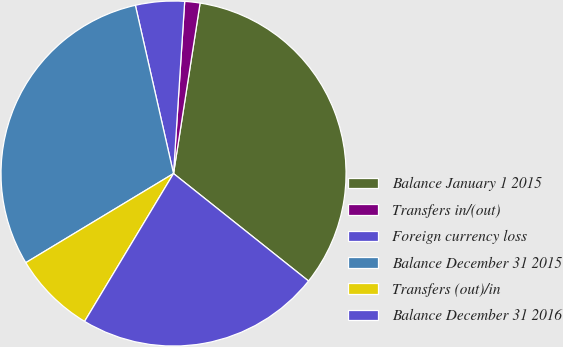Convert chart to OTSL. <chart><loc_0><loc_0><loc_500><loc_500><pie_chart><fcel>Balance January 1 2015<fcel>Transfers in/(out)<fcel>Foreign currency loss<fcel>Balance December 31 2015<fcel>Transfers (out)/in<fcel>Balance December 31 2016<nl><fcel>33.24%<fcel>1.43%<fcel>4.58%<fcel>30.09%<fcel>7.74%<fcel>22.92%<nl></chart> 